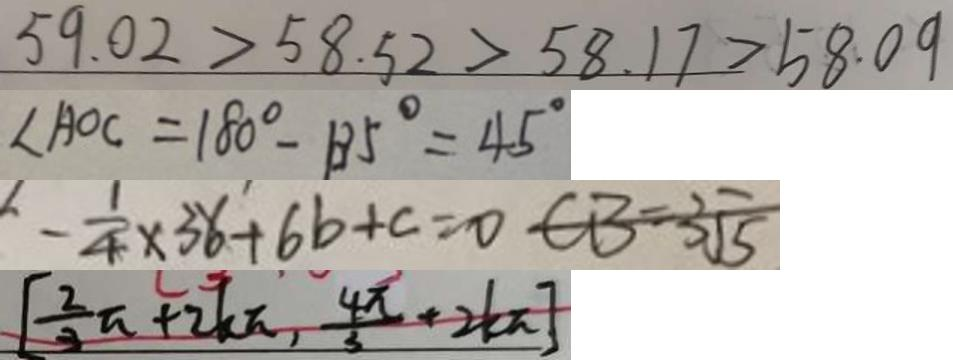<formula> <loc_0><loc_0><loc_500><loc_500>5 9 . 0 2 > 5 8 . 5 2 > 5 8 . 1 7 > 5 8 . 0 9 
 \angle A O C = 1 8 0 ^ { \circ } - 1 3 5 ^ { \circ } = 4 5 ^ { \circ } 
 - \frac { 1 } { 4 } \times 3 6 + 6 b + c = 0 C B = 3 \sqrt { 5 } 
 [ \frac { 2 } { 3 } \pi + 2 k \pi , \frac { 4 \pi } { 3 } + 2 k \pi ]</formula> 